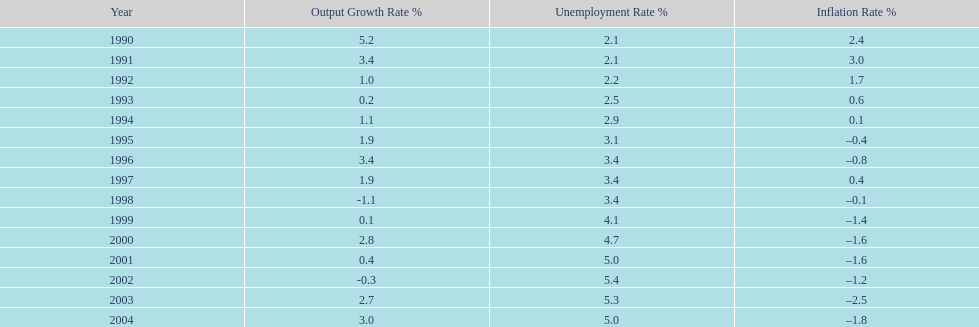What year had the highest unemployment rate? 2002. 